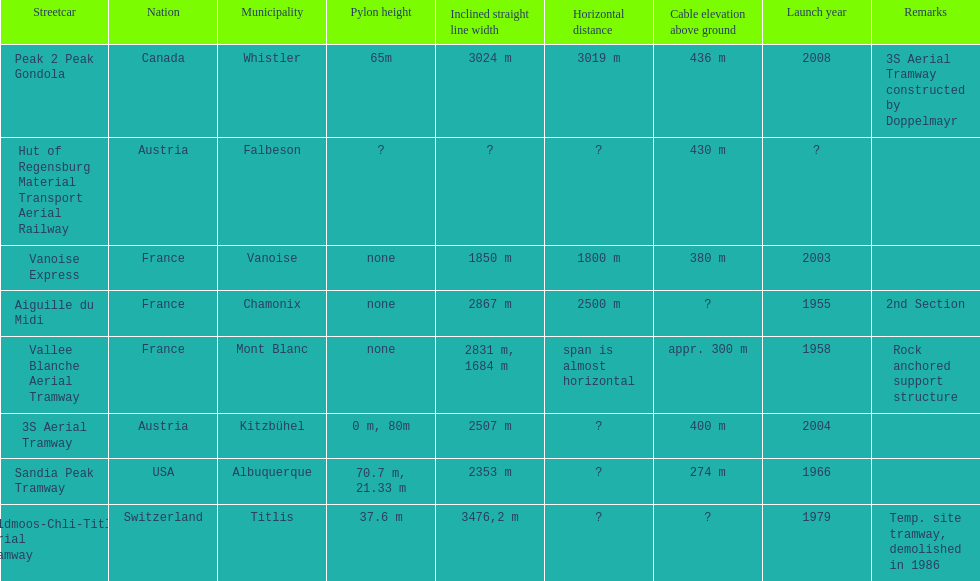In france, how many aerial tramways can be found? 3. 